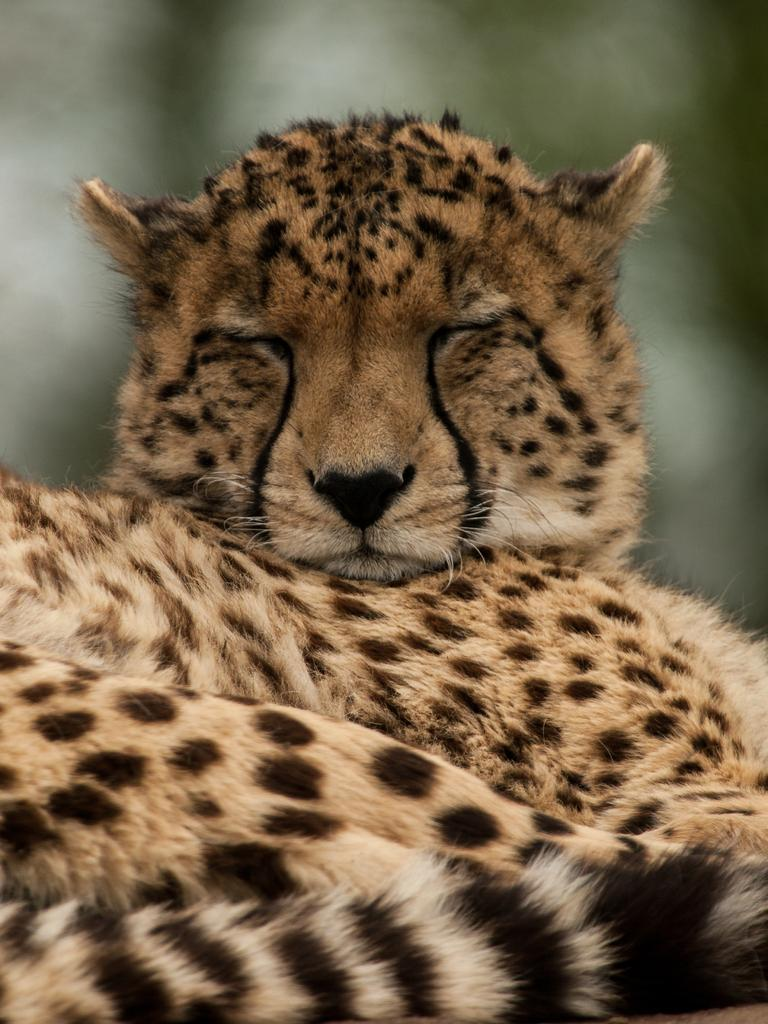What animal is in the foreground of the image? There is a tiger in the foreground of the image. Can you describe the background of the image? The background of the image is blurry. What type of hair can be seen on the tiger in the image? There is no hair visible on the tiger in the image; it is a tiger, which is a type of big cat with fur. What type of soda can be seen in the image? There is no soda present in the image. 